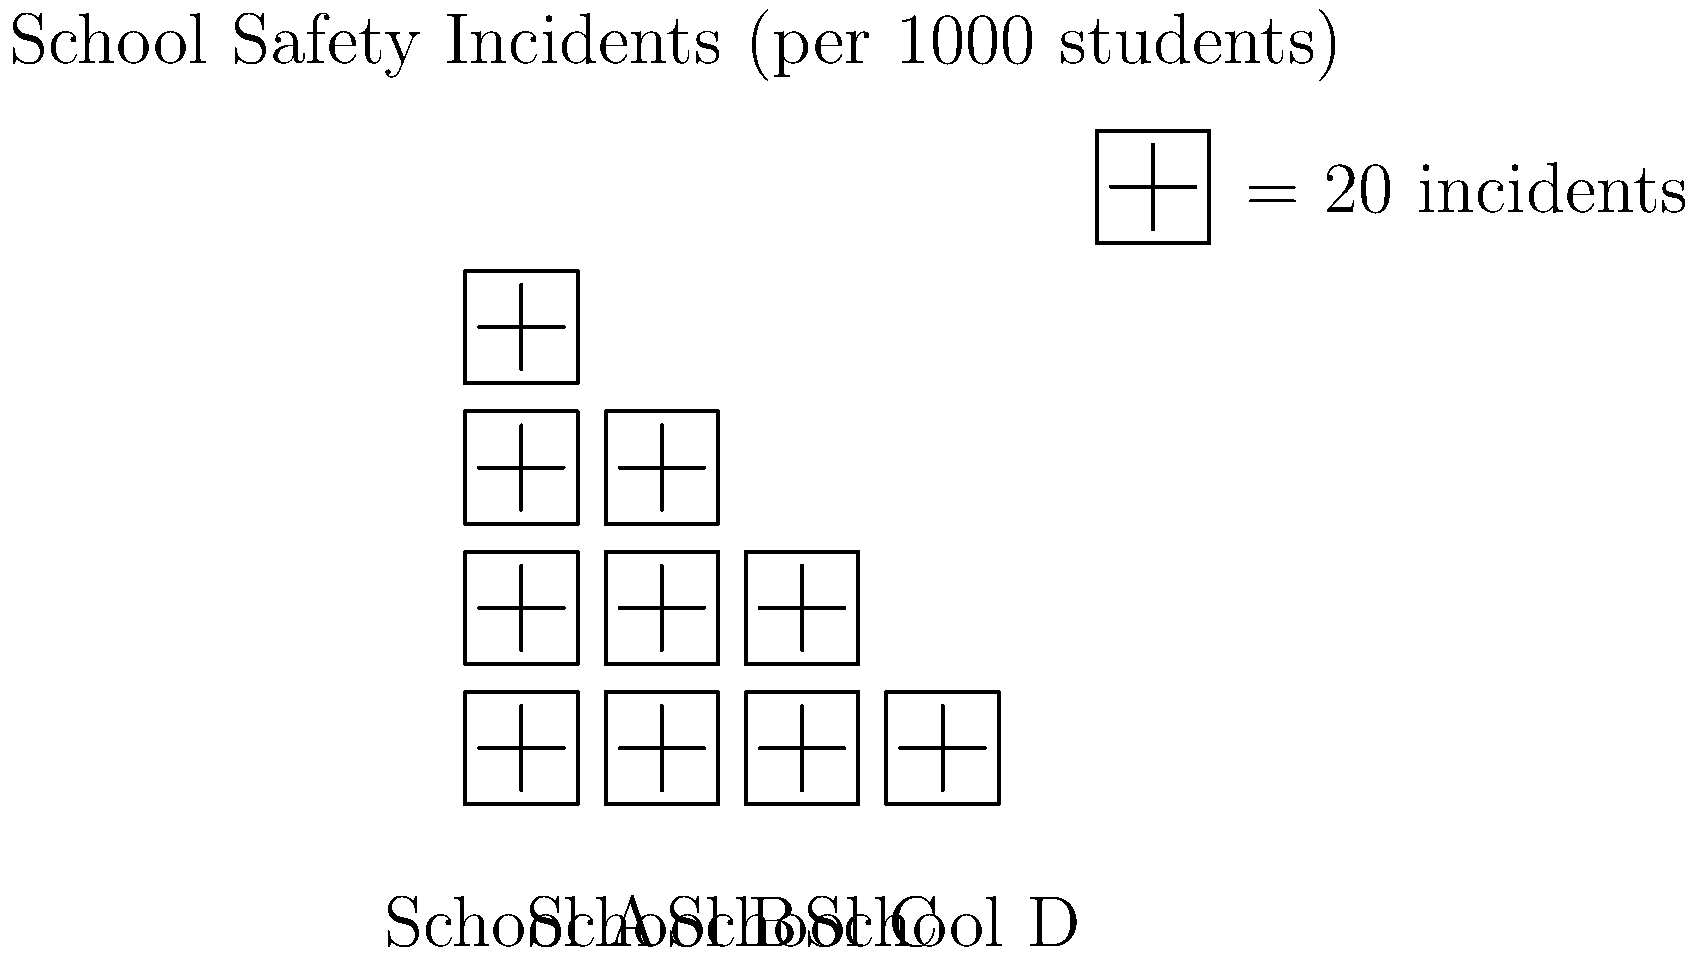Based on the pictograph showing school safety incidents per 1000 students, what is the difference in the number of incidents between the school with the highest rate and the school with the lowest rate? To solve this problem, we need to follow these steps:

1. Identify the schools with the highest and lowest incident rates:
   - School A has 4 icons = 80 incidents per 1000 students (highest)
   - School D has 1 icon = 20 incidents per 1000 students (lowest)

2. Calculate the difference:
   $$ \text{Difference} = \text{Highest rate} - \text{Lowest rate} $$
   $$ \text{Difference} = 80 - 20 = 60 \text{ incidents per 1000 students} $$

Therefore, the difference in the number of incidents between the school with the highest rate (School A) and the school with the lowest rate (School D) is 60 incidents per 1000 students.
Answer: 60 incidents per 1000 students 